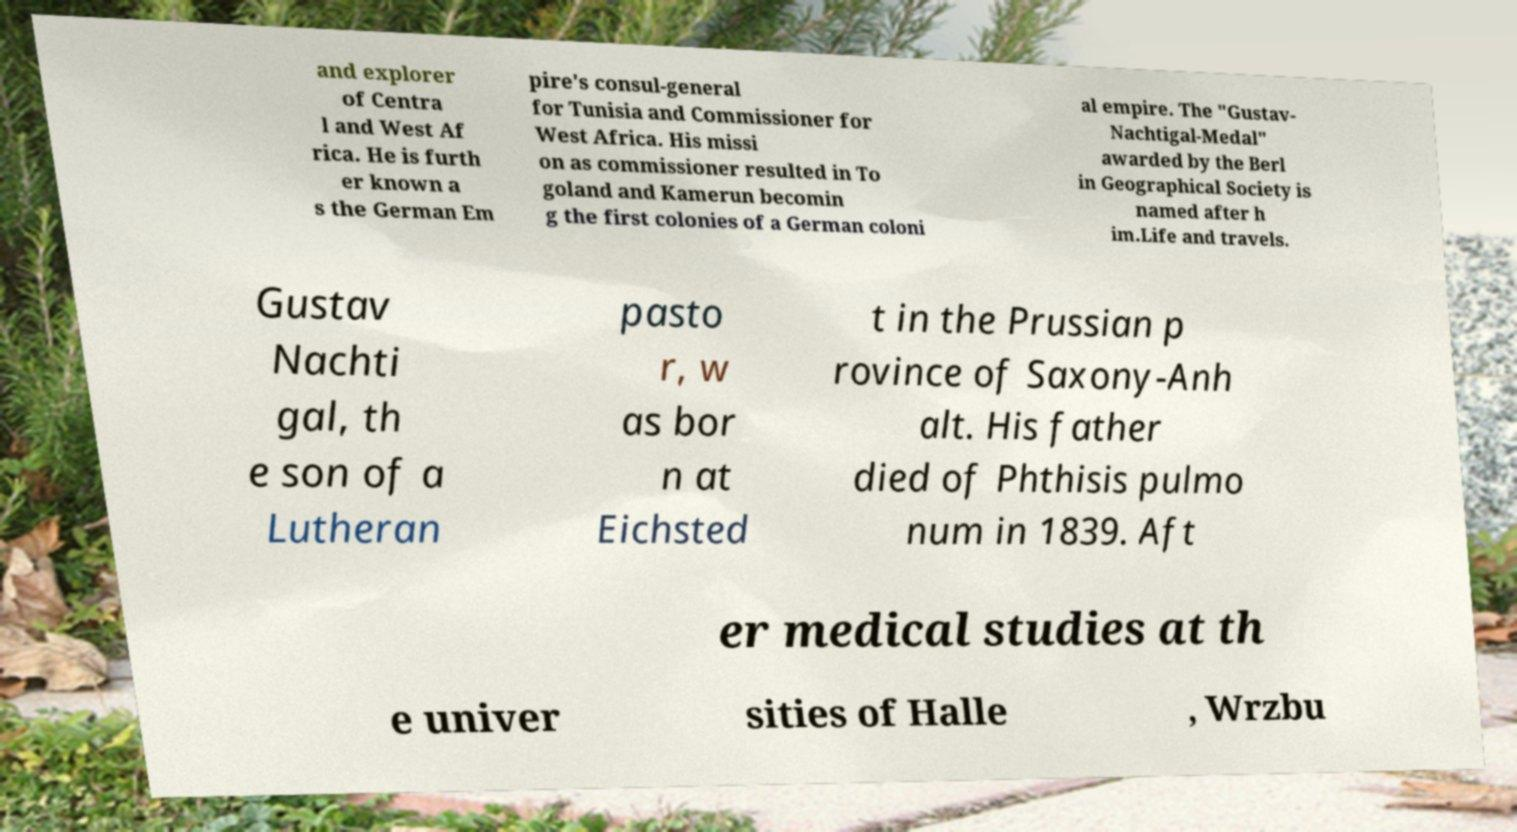Please read and relay the text visible in this image. What does it say? and explorer of Centra l and West Af rica. He is furth er known a s the German Em pire's consul-general for Tunisia and Commissioner for West Africa. His missi on as commissioner resulted in To goland and Kamerun becomin g the first colonies of a German coloni al empire. The "Gustav- Nachtigal-Medal" awarded by the Berl in Geographical Society is named after h im.Life and travels. Gustav Nachti gal, th e son of a Lutheran pasto r, w as bor n at Eichsted t in the Prussian p rovince of Saxony-Anh alt. His father died of Phthisis pulmo num in 1839. Aft er medical studies at th e univer sities of Halle , Wrzbu 